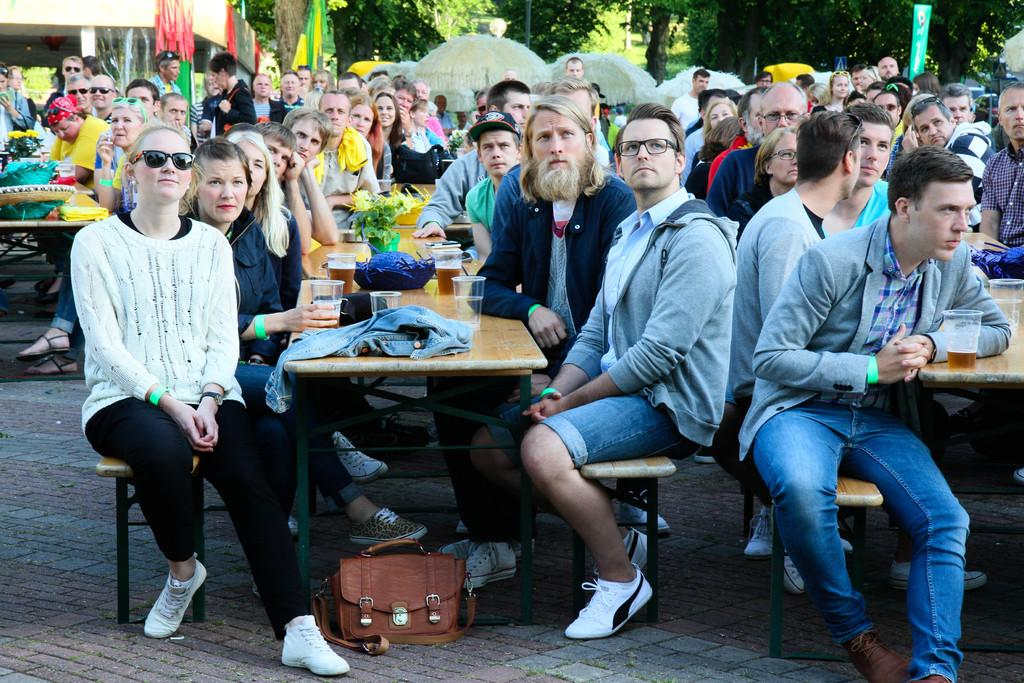What are the people in the image doing? The people in the image are sitting on benches. What objects are in front of the people? There are tables in front of the people. What can be seen on the tables? There are many things on the tables. What can be seen in the distance in the image? There are trees visible in the background of the image. What type of lift can be seen in the image? There is no lift present in the image. What color are the teeth of the people sitting on the benches? There is no indication of the people's teeth in the image, as their mouths are not visible. 